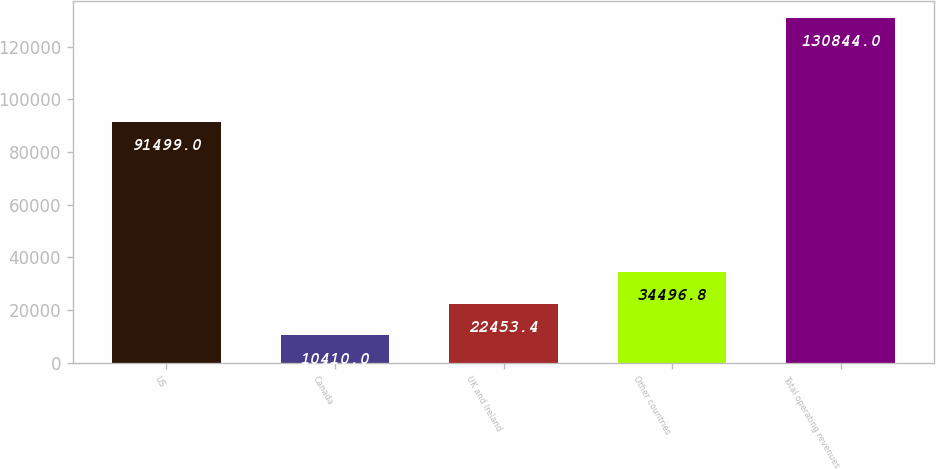Convert chart to OTSL. <chart><loc_0><loc_0><loc_500><loc_500><bar_chart><fcel>US<fcel>Canada<fcel>UK and Ireland<fcel>Other countries<fcel>Total operating revenues<nl><fcel>91499<fcel>10410<fcel>22453.4<fcel>34496.8<fcel>130844<nl></chart> 